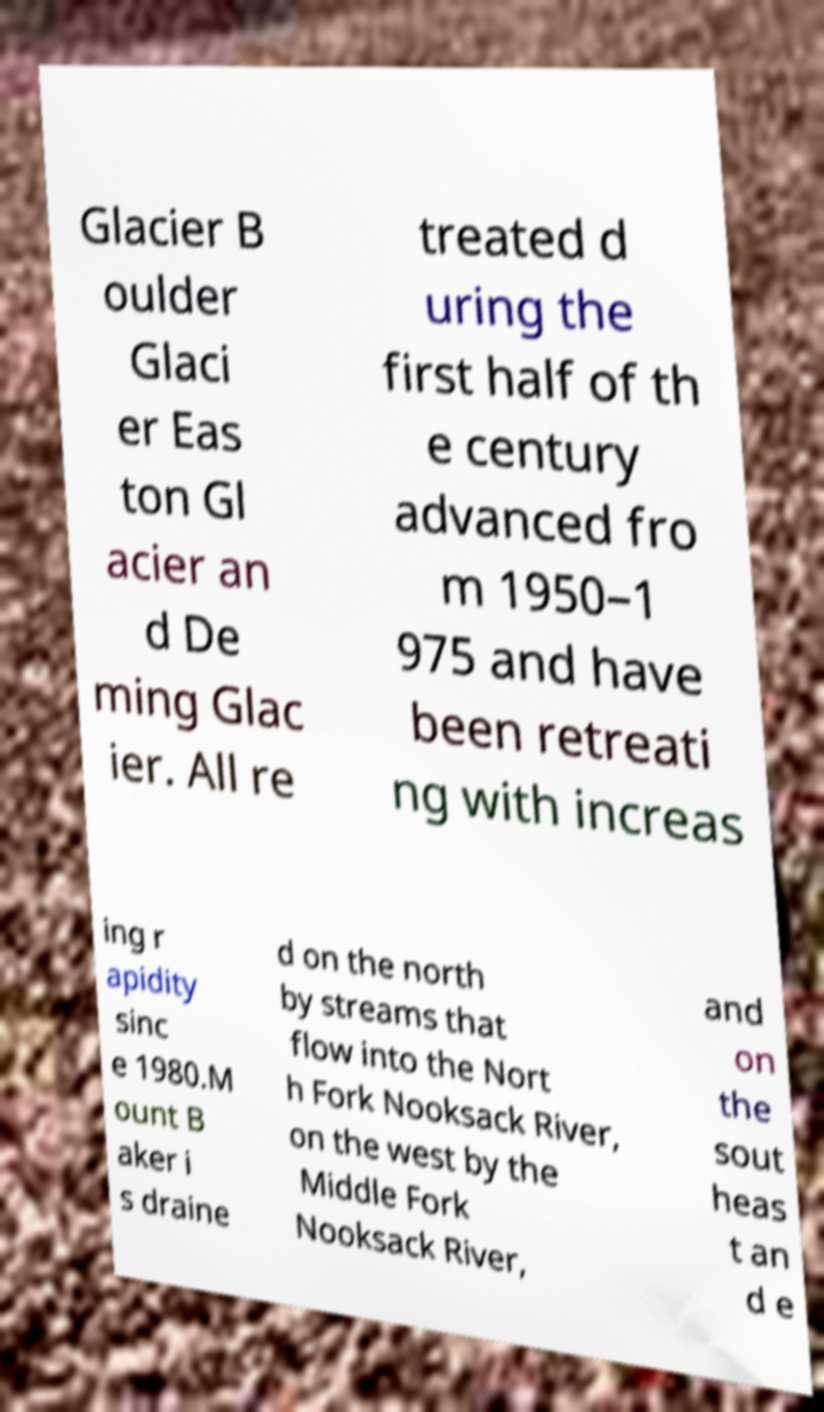Can you read and provide the text displayed in the image?This photo seems to have some interesting text. Can you extract and type it out for me? Glacier B oulder Glaci er Eas ton Gl acier an d De ming Glac ier. All re treated d uring the first half of th e century advanced fro m 1950–1 975 and have been retreati ng with increas ing r apidity sinc e 1980.M ount B aker i s draine d on the north by streams that flow into the Nort h Fork Nooksack River, on the west by the Middle Fork Nooksack River, and on the sout heas t an d e 